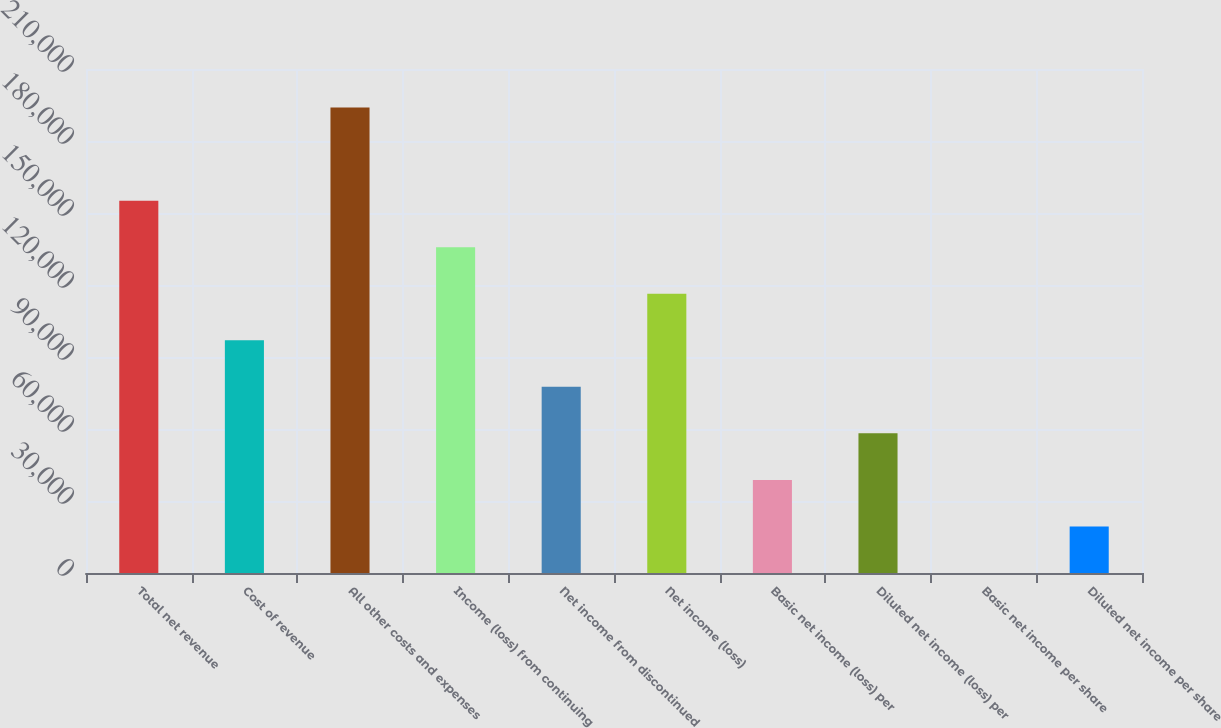Convert chart to OTSL. <chart><loc_0><loc_0><loc_500><loc_500><bar_chart><fcel>Total net revenue<fcel>Cost of revenue<fcel>All other costs and expenses<fcel>Income (loss) from continuing<fcel>Net income from discontinued<fcel>Net income (loss)<fcel>Basic net income (loss) per<fcel>Diluted net income (loss) per<fcel>Basic net income per share<fcel>Diluted net income per share<nl><fcel>155142<fcel>96964<fcel>193928<fcel>135750<fcel>77571.2<fcel>116357<fcel>38785.6<fcel>58178.4<fcel>0.06<fcel>19392.8<nl></chart> 